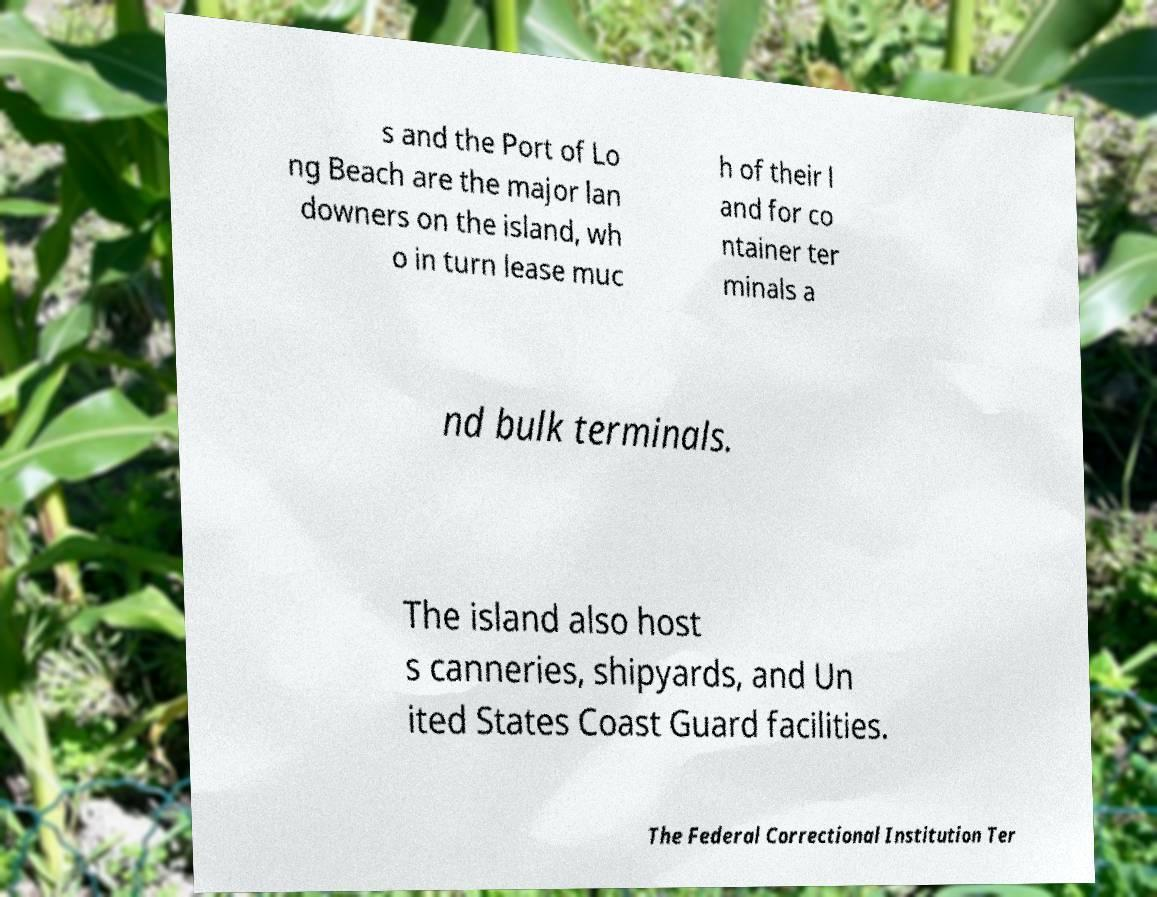Please read and relay the text visible in this image. What does it say? s and the Port of Lo ng Beach are the major lan downers on the island, wh o in turn lease muc h of their l and for co ntainer ter minals a nd bulk terminals. The island also host s canneries, shipyards, and Un ited States Coast Guard facilities. The Federal Correctional Institution Ter 